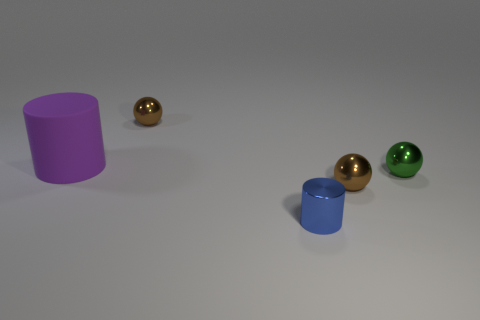Are there any objects with a similar shape to the purple cylinder? No, there are no other objects in the image with a cylindrical shape similar to the purple cylinder. 